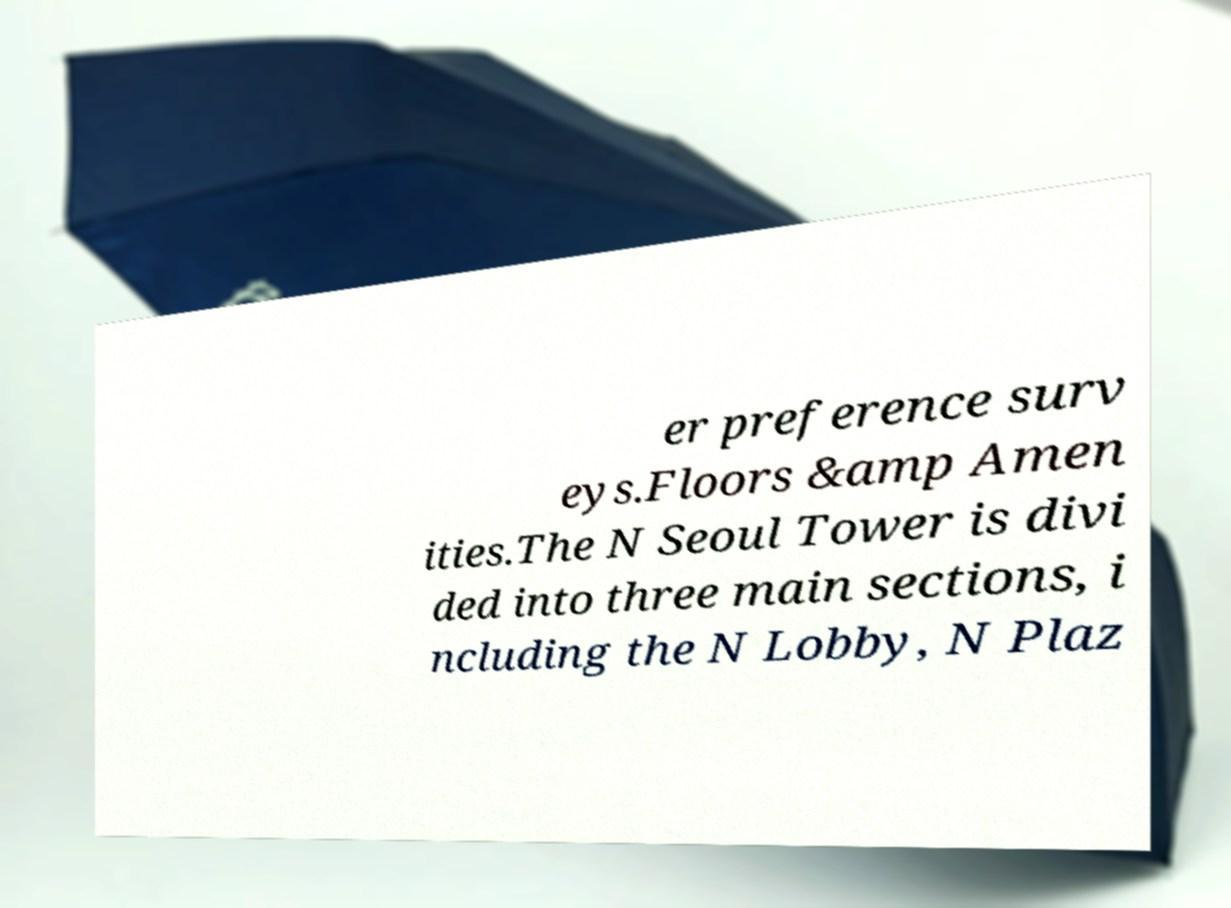Could you assist in decoding the text presented in this image and type it out clearly? er preference surv eys.Floors &amp Amen ities.The N Seoul Tower is divi ded into three main sections, i ncluding the N Lobby, N Plaz 